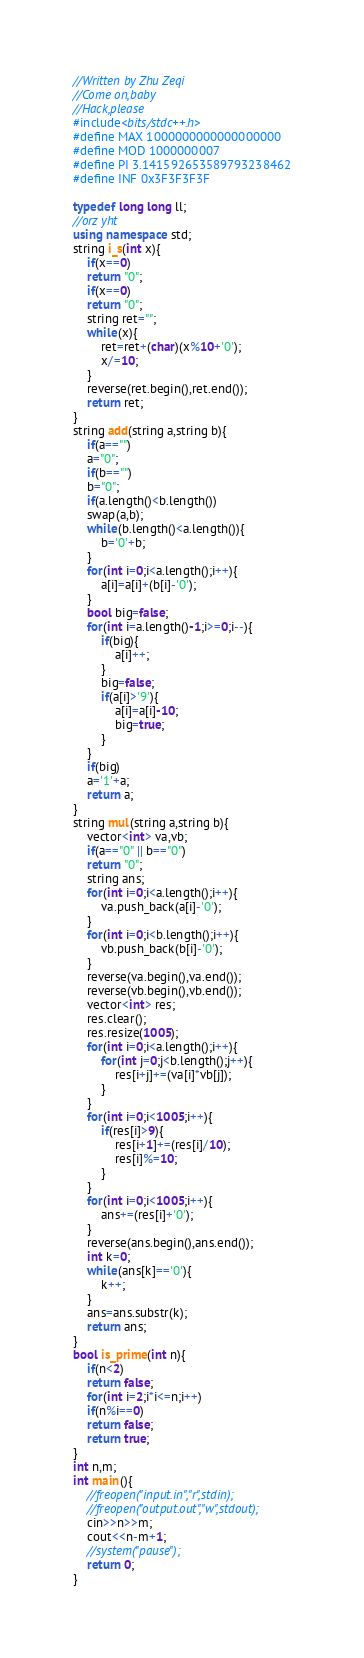Convert code to text. <code><loc_0><loc_0><loc_500><loc_500><_C++_>//Written by Zhu Zeqi
//Come on,baby
//Hack,please
#include<bits/stdc++.h>
#define MAX 1000000000000000000
#define MOD 1000000007
#define PI 3.141592653589793238462
#define INF 0x3F3F3F3F

typedef long long ll;
//orz yht
using namespace std;
string i_s(int x){
	if(x==0)
	return "0";
	if(x==0)
	return "0";
	string ret="";
	while(x){
		ret=ret+(char)(x%10+'0');
		x/=10;
	}
	reverse(ret.begin(),ret.end());
	return ret;
}
string add(string a,string b){
	if(a=="")
	a="0";
	if(b=="")
	b="0";
	if(a.length()<b.length())
	swap(a,b);
	while(b.length()<a.length()){
		b='0'+b;
	}
	for(int i=0;i<a.length();i++){
		a[i]=a[i]+(b[i]-'0');
	}
	bool big=false;
	for(int i=a.length()-1;i>=0;i--){
		if(big){
			a[i]++;
		}
		big=false;
		if(a[i]>'9'){
			a[i]=a[i]-10;
			big=true;
		}
	}
	if(big)
	a='1'+a;
	return a;
}
string mul(string a,string b){
	vector<int> va,vb;
	if(a=="0" || b=="0")
	return "0";
	string ans;
	for(int i=0;i<a.length();i++){
		va.push_back(a[i]-'0');
	}
	for(int i=0;i<b.length();i++){
		vb.push_back(b[i]-'0');
	}
	reverse(va.begin(),va.end());
	reverse(vb.begin(),vb.end());
	vector<int> res;
	res.clear();
	res.resize(1005);
	for(int i=0;i<a.length();i++){
		for(int j=0;j<b.length();j++){
			res[i+j]+=(va[i]*vb[j]);
		}
	}
	for(int i=0;i<1005;i++){
		if(res[i]>9){
			res[i+1]+=(res[i]/10);
			res[i]%=10;
		}
	}
	for(int i=0;i<1005;i++){
		ans+=(res[i]+'0');
	}
	reverse(ans.begin(),ans.end());
	int k=0;
	while(ans[k]=='0'){
		k++;
	}
	ans=ans.substr(k);
	return ans;
}
bool is_prime(int n){
	if(n<2)
    return false;
    for(int i=2;i*i<=n;i++)
    if(n%i==0)
    return false;
    return true;
}
int n,m;
int main(){
	//freopen("input.in","r",stdin);
	//freopen("output.out","w",stdout);
	cin>>n>>m;
	cout<<n-m+1;
	//system("pause");
	return 0;
}
</code> 